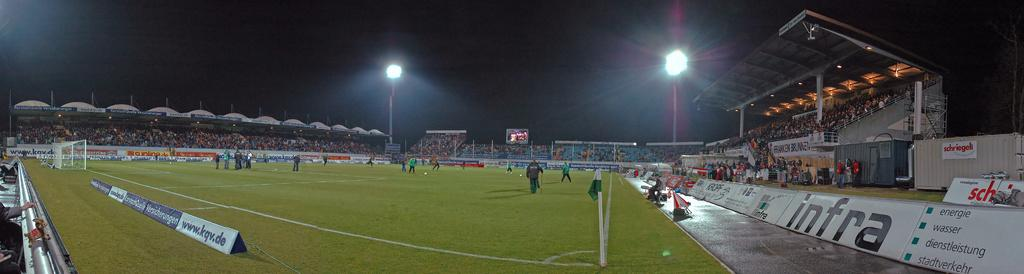<image>
Offer a succinct explanation of the picture presented. A soccer field is bordered by a number of ads for different companies, such as infra and KQV. 